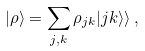<formula> <loc_0><loc_0><loc_500><loc_500>| \rho \rangle = \sum _ { j , k } \rho _ { j k } | j k \rangle \rangle \, ,</formula> 